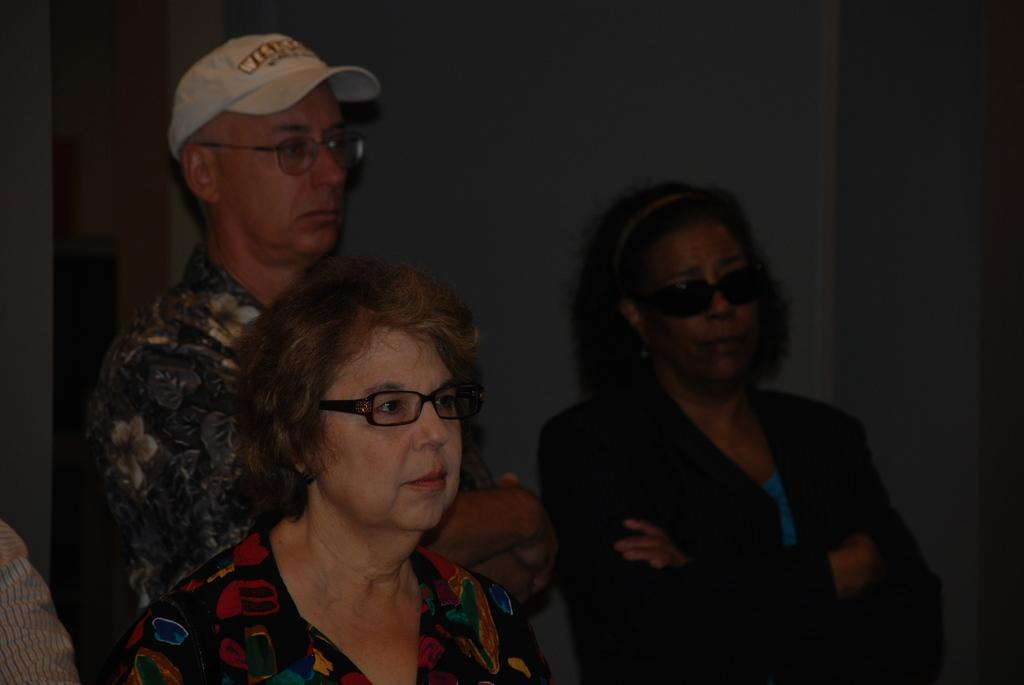What is the gender of the person on the left side of the image? There is a woman on the left side of the image. What is the woman on the left side wearing? The woman on the left side is wearing spectacles. Can you describe the person behind the woman on the left side? There is a man behind the woman on the left side, and he is wearing a cap. What is the gender of the person on the right side of the image? There is a woman on the right side of the image. What is the woman on the right side wearing on her face? The woman on the right side is wearing black color spectacles. What type of clothing is the woman on the right side wearing? The woman on the right side is wearing a coat. What type of skirt is the woman on the left side wearing? There is no mention of a skirt in the image; the woman on the left side is wearing spectacles. What type of crime is being committed in the image? There is no mention of a crime in the image; it depicts people wearing spectacles and a cap. 